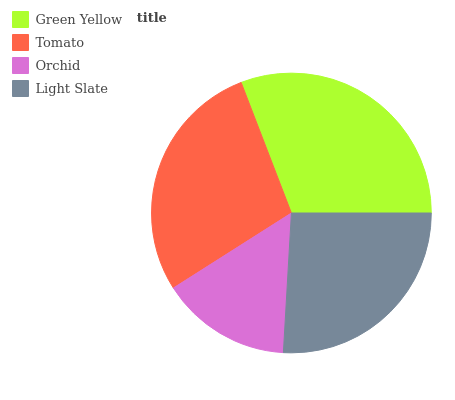Is Orchid the minimum?
Answer yes or no. Yes. Is Green Yellow the maximum?
Answer yes or no. Yes. Is Tomato the minimum?
Answer yes or no. No. Is Tomato the maximum?
Answer yes or no. No. Is Green Yellow greater than Tomato?
Answer yes or no. Yes. Is Tomato less than Green Yellow?
Answer yes or no. Yes. Is Tomato greater than Green Yellow?
Answer yes or no. No. Is Green Yellow less than Tomato?
Answer yes or no. No. Is Tomato the high median?
Answer yes or no. Yes. Is Light Slate the low median?
Answer yes or no. Yes. Is Light Slate the high median?
Answer yes or no. No. Is Green Yellow the low median?
Answer yes or no. No. 